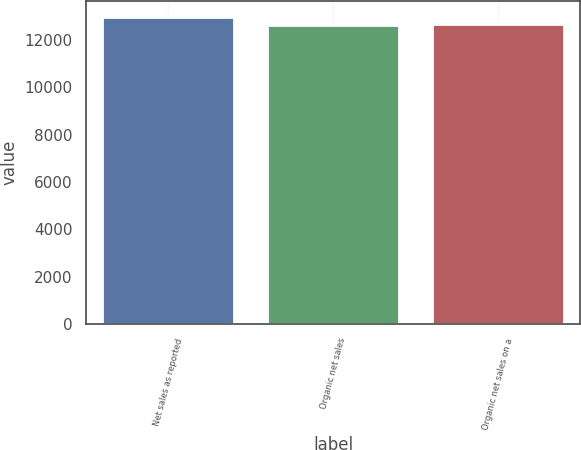<chart> <loc_0><loc_0><loc_500><loc_500><bar_chart><fcel>Net sales as reported<fcel>Organic net sales<fcel>Organic net sales on a<nl><fcel>12988.7<fcel>12638<fcel>12673.1<nl></chart> 